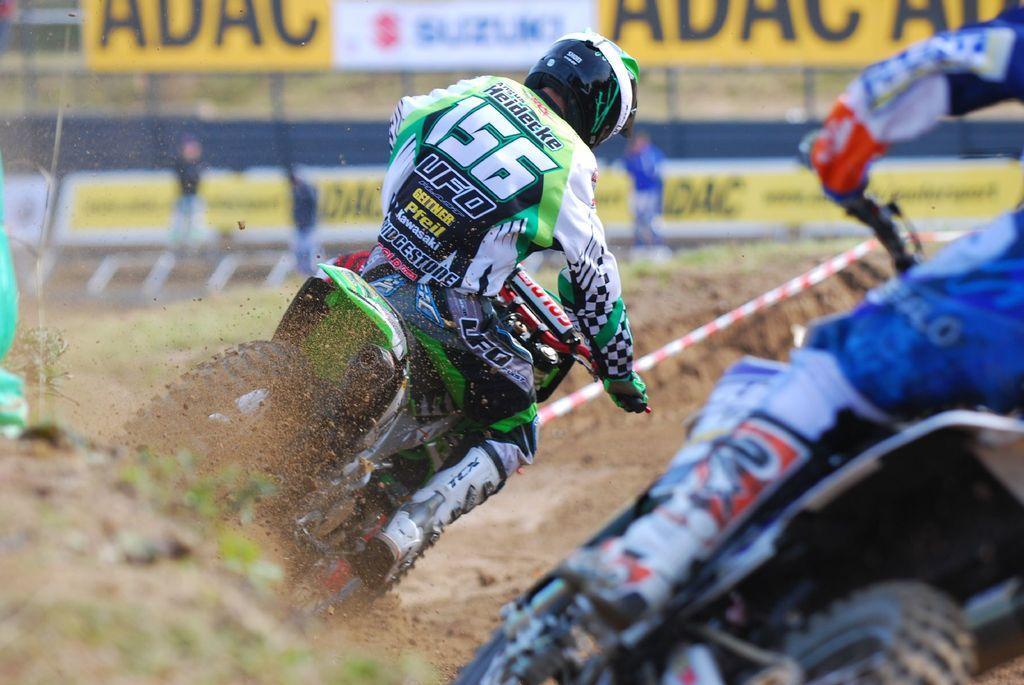Can you describe this image briefly? This picture is clicked outside. On the right we can see the two persons wearing helmets and riding bikes. In the background we can see the banners on which we can see the text and we can see many other objects. 